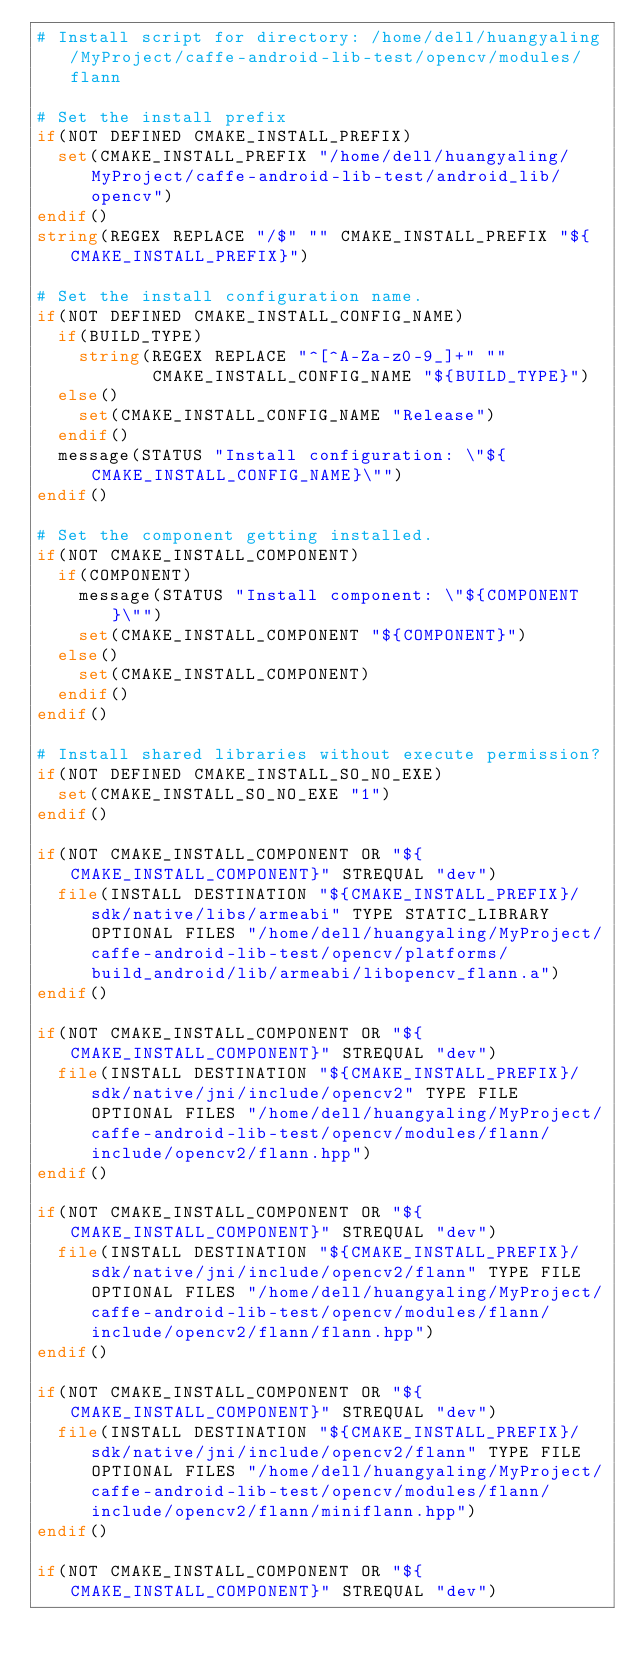<code> <loc_0><loc_0><loc_500><loc_500><_CMake_># Install script for directory: /home/dell/huangyaling/MyProject/caffe-android-lib-test/opencv/modules/flann

# Set the install prefix
if(NOT DEFINED CMAKE_INSTALL_PREFIX)
  set(CMAKE_INSTALL_PREFIX "/home/dell/huangyaling/MyProject/caffe-android-lib-test/android_lib/opencv")
endif()
string(REGEX REPLACE "/$" "" CMAKE_INSTALL_PREFIX "${CMAKE_INSTALL_PREFIX}")

# Set the install configuration name.
if(NOT DEFINED CMAKE_INSTALL_CONFIG_NAME)
  if(BUILD_TYPE)
    string(REGEX REPLACE "^[^A-Za-z0-9_]+" ""
           CMAKE_INSTALL_CONFIG_NAME "${BUILD_TYPE}")
  else()
    set(CMAKE_INSTALL_CONFIG_NAME "Release")
  endif()
  message(STATUS "Install configuration: \"${CMAKE_INSTALL_CONFIG_NAME}\"")
endif()

# Set the component getting installed.
if(NOT CMAKE_INSTALL_COMPONENT)
  if(COMPONENT)
    message(STATUS "Install component: \"${COMPONENT}\"")
    set(CMAKE_INSTALL_COMPONENT "${COMPONENT}")
  else()
    set(CMAKE_INSTALL_COMPONENT)
  endif()
endif()

# Install shared libraries without execute permission?
if(NOT DEFINED CMAKE_INSTALL_SO_NO_EXE)
  set(CMAKE_INSTALL_SO_NO_EXE "1")
endif()

if(NOT CMAKE_INSTALL_COMPONENT OR "${CMAKE_INSTALL_COMPONENT}" STREQUAL "dev")
  file(INSTALL DESTINATION "${CMAKE_INSTALL_PREFIX}/sdk/native/libs/armeabi" TYPE STATIC_LIBRARY OPTIONAL FILES "/home/dell/huangyaling/MyProject/caffe-android-lib-test/opencv/platforms/build_android/lib/armeabi/libopencv_flann.a")
endif()

if(NOT CMAKE_INSTALL_COMPONENT OR "${CMAKE_INSTALL_COMPONENT}" STREQUAL "dev")
  file(INSTALL DESTINATION "${CMAKE_INSTALL_PREFIX}/sdk/native/jni/include/opencv2" TYPE FILE OPTIONAL FILES "/home/dell/huangyaling/MyProject/caffe-android-lib-test/opencv/modules/flann/include/opencv2/flann.hpp")
endif()

if(NOT CMAKE_INSTALL_COMPONENT OR "${CMAKE_INSTALL_COMPONENT}" STREQUAL "dev")
  file(INSTALL DESTINATION "${CMAKE_INSTALL_PREFIX}/sdk/native/jni/include/opencv2/flann" TYPE FILE OPTIONAL FILES "/home/dell/huangyaling/MyProject/caffe-android-lib-test/opencv/modules/flann/include/opencv2/flann/flann.hpp")
endif()

if(NOT CMAKE_INSTALL_COMPONENT OR "${CMAKE_INSTALL_COMPONENT}" STREQUAL "dev")
  file(INSTALL DESTINATION "${CMAKE_INSTALL_PREFIX}/sdk/native/jni/include/opencv2/flann" TYPE FILE OPTIONAL FILES "/home/dell/huangyaling/MyProject/caffe-android-lib-test/opencv/modules/flann/include/opencv2/flann/miniflann.hpp")
endif()

if(NOT CMAKE_INSTALL_COMPONENT OR "${CMAKE_INSTALL_COMPONENT}" STREQUAL "dev")</code> 